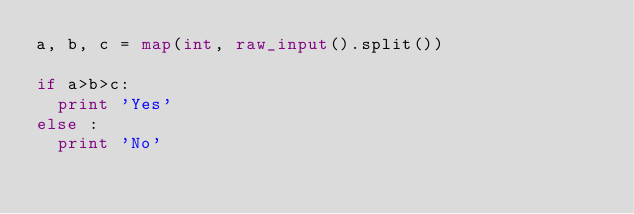Convert code to text. <code><loc_0><loc_0><loc_500><loc_500><_Python_>a, b, c = map(int, raw_input().split())
  
if a>b>c:
  print 'Yes'
else :
  print 'No'</code> 